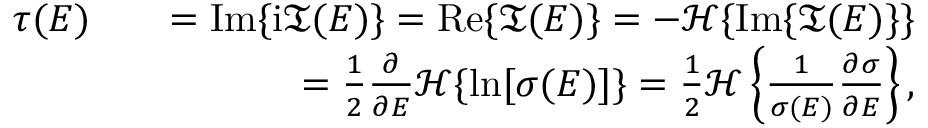<formula> <loc_0><loc_0><loc_500><loc_500>\begin{array} { r l r } { \tau ( E ) } & { = I m \{ i \mathfrak { T } ( E ) \} = R e \{ \mathfrak { T } ( E ) \} = - \mathcal { H } \{ I m \{ \mathfrak { T } ( E ) \} \} } \\ & { = \frac { 1 } { 2 } \frac { \partial } { \partial E } \mathcal { H } \{ \ln [ \sigma ( E ) ] \} = \frac { 1 } { 2 } \mathcal { H } \left \{ \frac { 1 } { \sigma ( E ) } \frac { \partial \sigma } { \partial E } \right \} , } \end{array}</formula> 